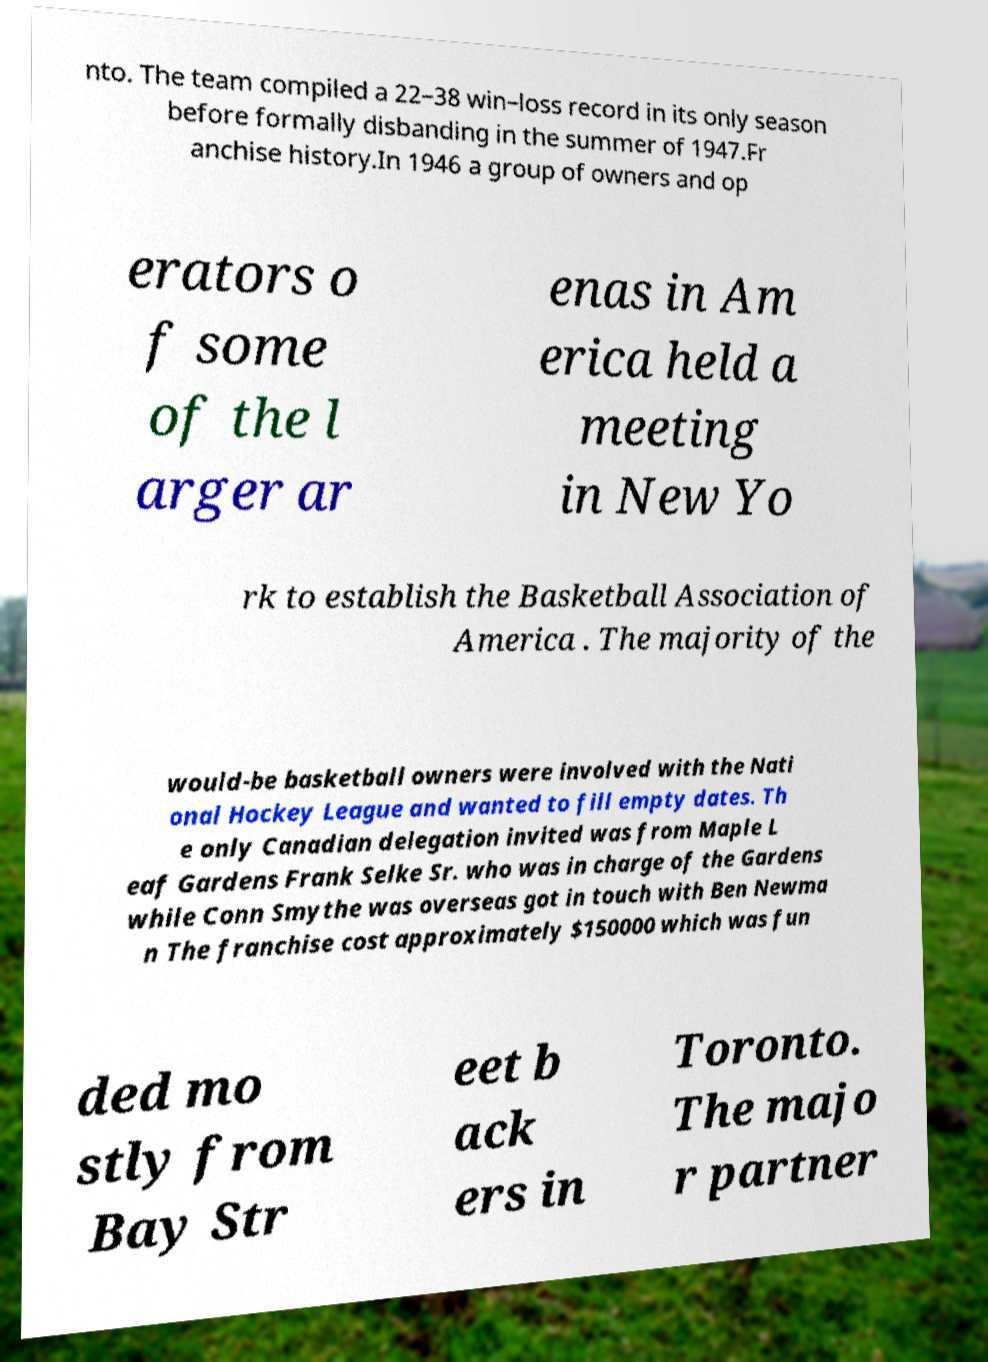For documentation purposes, I need the text within this image transcribed. Could you provide that? nto. The team compiled a 22–38 win–loss record in its only season before formally disbanding in the summer of 1947.Fr anchise history.In 1946 a group of owners and op erators o f some of the l arger ar enas in Am erica held a meeting in New Yo rk to establish the Basketball Association of America . The majority of the would-be basketball owners were involved with the Nati onal Hockey League and wanted to fill empty dates. Th e only Canadian delegation invited was from Maple L eaf Gardens Frank Selke Sr. who was in charge of the Gardens while Conn Smythe was overseas got in touch with Ben Newma n The franchise cost approximately $150000 which was fun ded mo stly from Bay Str eet b ack ers in Toronto. The majo r partner 